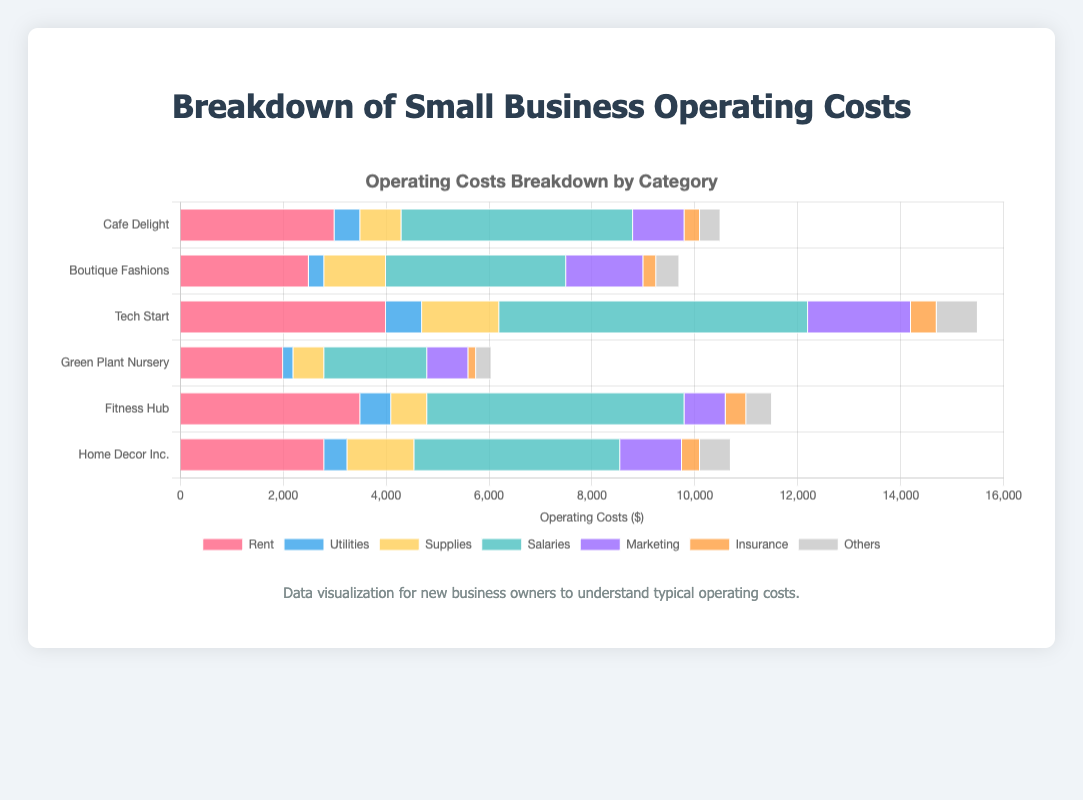Which small business has the highest total operating costs? To find this, add up the costs from all categories for each business. The sums are: Cafe Delight = 10400; Boutique Fashions = 9700; Tech Start = 15500; Green Plant Nursery = 6050; Fitness Hub = 11100; Home Decor Inc. = 10400. Tech Start has the highest total operating costs.
Answer: Tech Start What are the total operating costs for boutique Fashions and Fitness Hub combined? Add the total operating costs for each business: Boutique Fashions = 9700 and Fitness Hub = 11100. Therefore, the combined total is 9700 + 11100 = 20800.
Answer: 20800 Which business has the lowest expenditure on insurance? Comparing the insurance costs, we have: Cafe Delight = 300; Boutique Fashions = 250; Tech Start = 500; Green Plant Nursery = 150; Fitness Hub = 400; Home Decor Inc. = 350. Green Plant Nursery has the lowest expenditure on insurance.
Answer: Green Plant Nursery In terms of salary expenses, which business spends more: Home Decor Inc. or Fitness Hub? Comparing salary expenses: Home Decor Inc. = 4000 and Fitness Hub = 5000. Therefore, Fitness Hub spends more on salaries.
Answer: Fitness Hub How much more does Tech Start spend on marketing compared to Green Plant Nursery? Tech Start spends $2000 on marketing, while Green Plant Nursery spends $800. The difference is 2000 - 800 = 1200.
Answer: 1200 Which category has the smallest visual representation in Cafe Delight's bar? In Cafe Delight's bar, the category with the smallest representation is Insurance which is depicted last in the sequence of the stacked bar and shorter than the others.
Answer: Insurance Out of the total expenses for Rent, identify which business has the second-highest rent costs. Comparing rent costs: Cafe Delight = 3000, Boutique Fashions = 2500, Tech Start = 4000, Green Plant Nursery = 2000, Fitness Hub = 3500, Home Decor Inc. = 2800. The second-highest is Fitness Hub with a rent of 3500.
Answer: Fitness Hub 